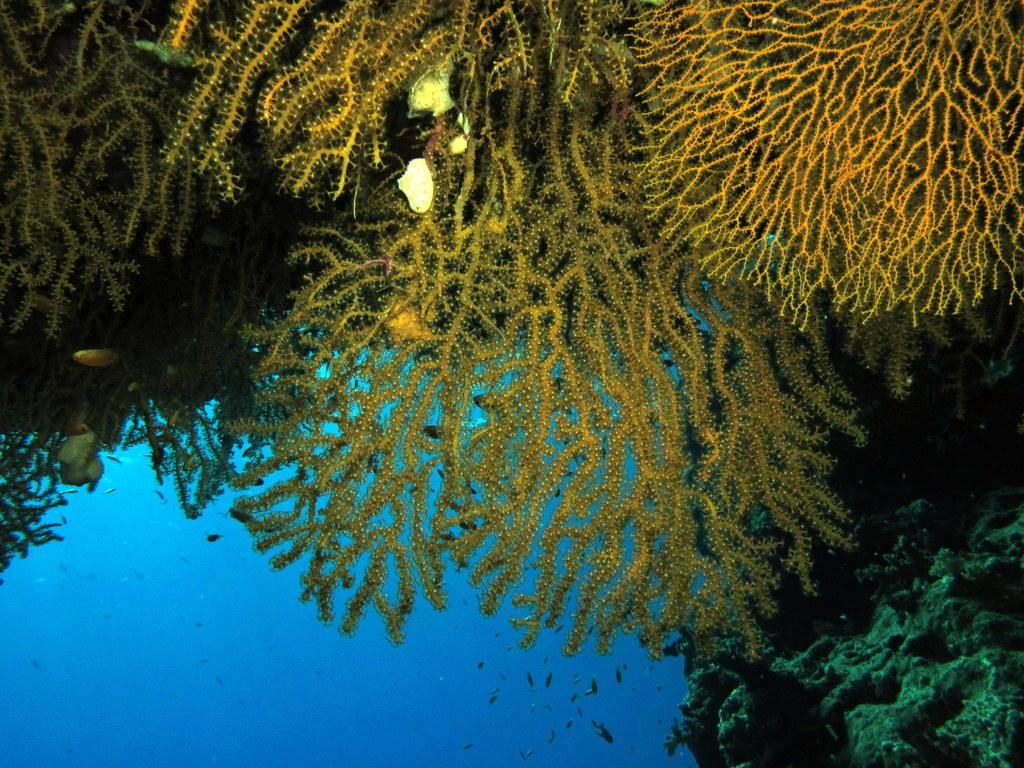What type of marine life can be seen in the image? There are corals and fishes in the image. Where are the corals and fishes located? The corals and fishes are in the water. Can you describe the environment in which the corals and fishes are found? The corals and fishes are located in a watery environment. What type of rhythm can be heard from the corals in the image? There is no sound or rhythm associated with the corals in the image; they are a visual subject. 